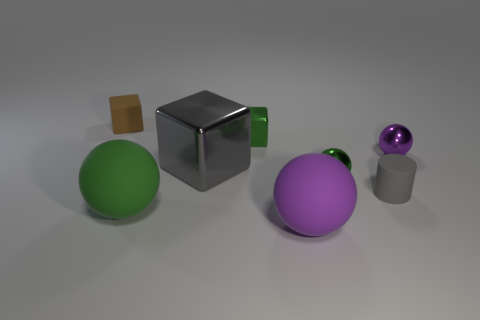Do the gray block and the brown cube have the same material?
Offer a very short reply. No. How many green objects are small rubber cylinders or tiny shiny things?
Your answer should be very brief. 2. There is a large green rubber sphere; what number of purple objects are behind it?
Your answer should be very brief. 1. Are there more big green blocks than shiny spheres?
Your answer should be compact. No. There is a large purple object that is in front of the small cube in front of the tiny brown rubber thing; what shape is it?
Your response must be concise. Sphere. Is the color of the tiny metallic block the same as the small rubber cube?
Offer a very short reply. No. Is the number of brown cubes that are in front of the tiny brown matte object greater than the number of large brown rubber cylinders?
Your response must be concise. No. There is a small green metal cube to the left of the purple rubber object; what number of small green objects are in front of it?
Your answer should be very brief. 1. Does the green ball behind the green rubber ball have the same material as the tiny object to the left of the big gray block?
Offer a very short reply. No. There is a block that is the same color as the matte cylinder; what is its material?
Offer a terse response. Metal. 